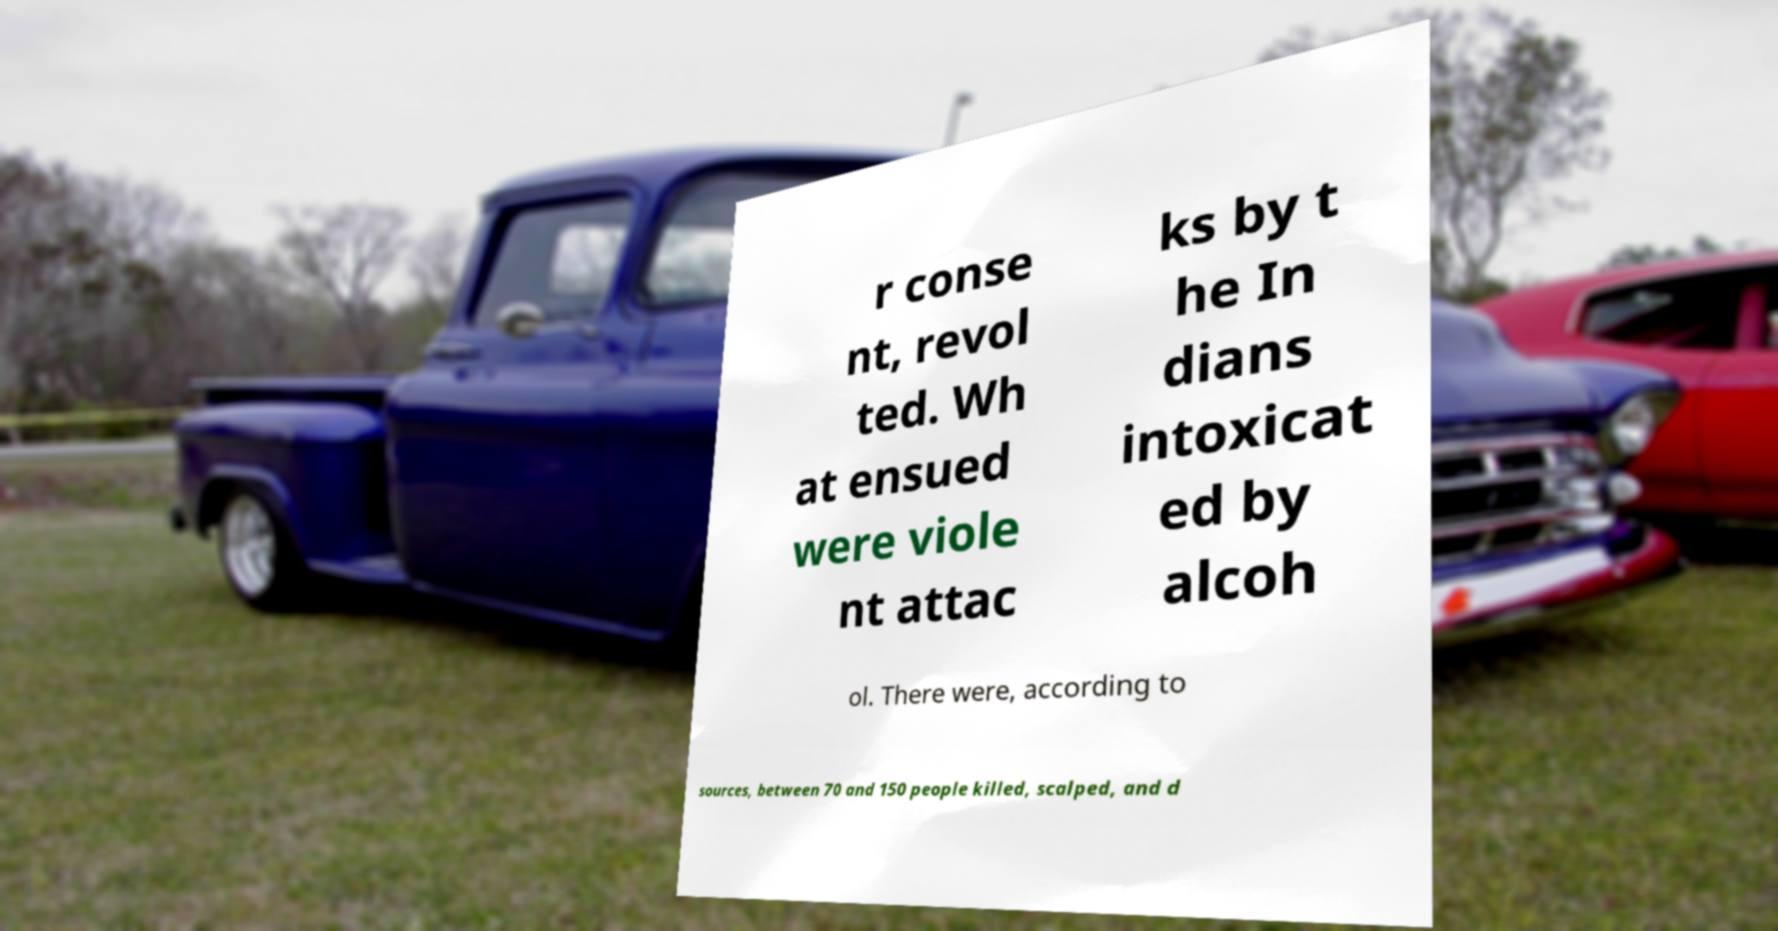Can you accurately transcribe the text from the provided image for me? r conse nt, revol ted. Wh at ensued were viole nt attac ks by t he In dians intoxicat ed by alcoh ol. There were, according to sources, between 70 and 150 people killed, scalped, and d 